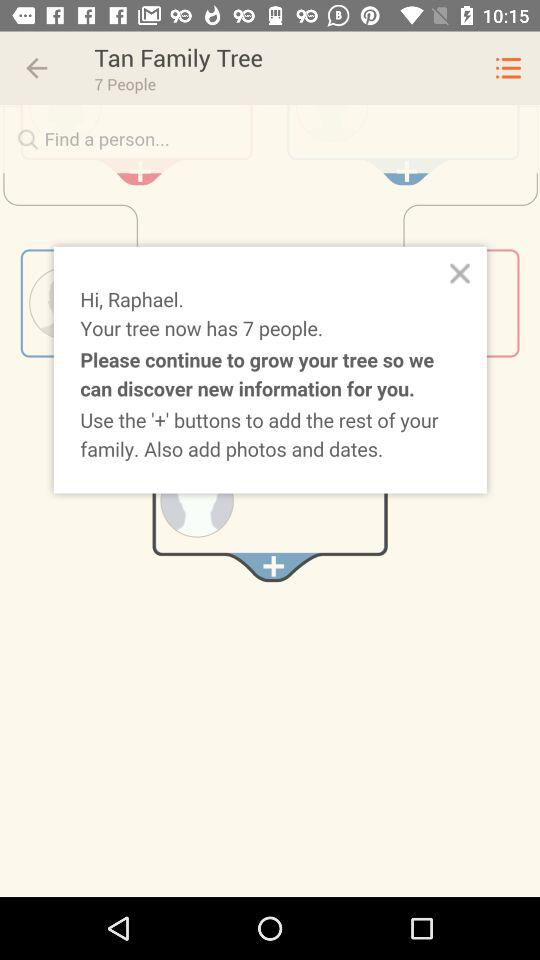What buttons can we use to add the family members? You can use the + button. 